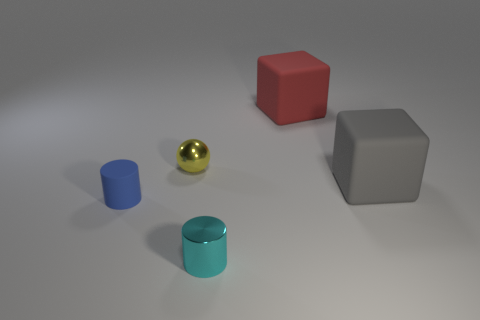There is a blue thing that is made of the same material as the gray cube; what size is it?
Offer a very short reply. Small. What number of other red matte objects have the same shape as the red matte object?
Provide a short and direct response. 0. How many things are large things that are to the right of the large red thing or big rubber things that are behind the gray matte thing?
Provide a succinct answer. 2. There is a tiny cylinder that is in front of the tiny blue rubber object; how many red matte cubes are behind it?
Offer a very short reply. 1. There is a large object that is on the right side of the large red rubber object; is it the same shape as the rubber object behind the yellow ball?
Give a very brief answer. Yes. Is there a big red cube made of the same material as the blue object?
Make the answer very short. Yes. How many rubber objects are blue objects or small cylinders?
Ensure brevity in your answer.  1. There is a big object that is in front of the big rubber block that is behind the yellow shiny sphere; what is its shape?
Your answer should be compact. Cube. Is the number of tiny things right of the blue rubber thing less than the number of tiny cyan shiny objects?
Keep it short and to the point. No. The big red rubber thing has what shape?
Ensure brevity in your answer.  Cube. 